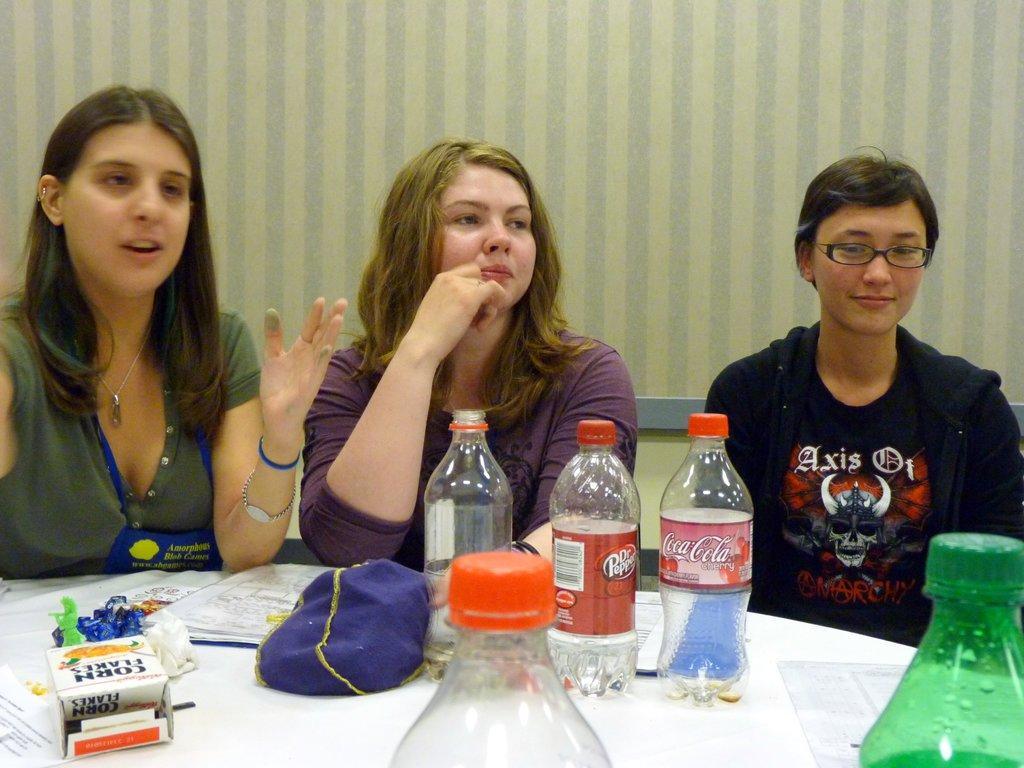Can you describe this image briefly? In the middle of the image there women are sitting on the bench. In front of them there is a table on the table there are some bottles and papers, Behind them there is a wall. 